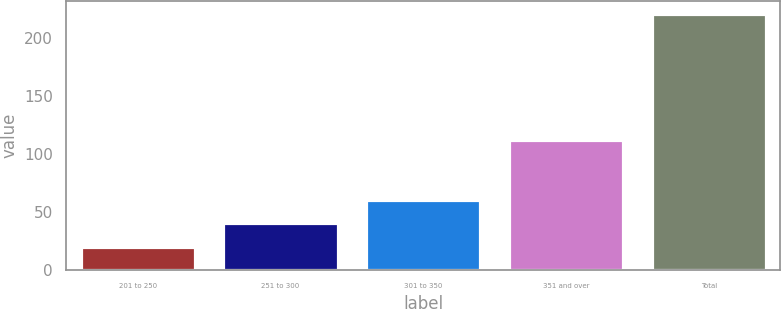Convert chart to OTSL. <chart><loc_0><loc_0><loc_500><loc_500><bar_chart><fcel>201 to 250<fcel>251 to 300<fcel>301 to 350<fcel>351 and over<fcel>Total<nl><fcel>20.2<fcel>40.26<fcel>60.32<fcel>111.9<fcel>220.8<nl></chart> 